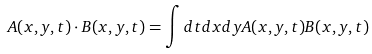Convert formula to latex. <formula><loc_0><loc_0><loc_500><loc_500>A ( x , y , t ) \cdot B ( x , y , t ) = \int d t d x d y A ( x , y , t ) B ( x , y , t )</formula> 